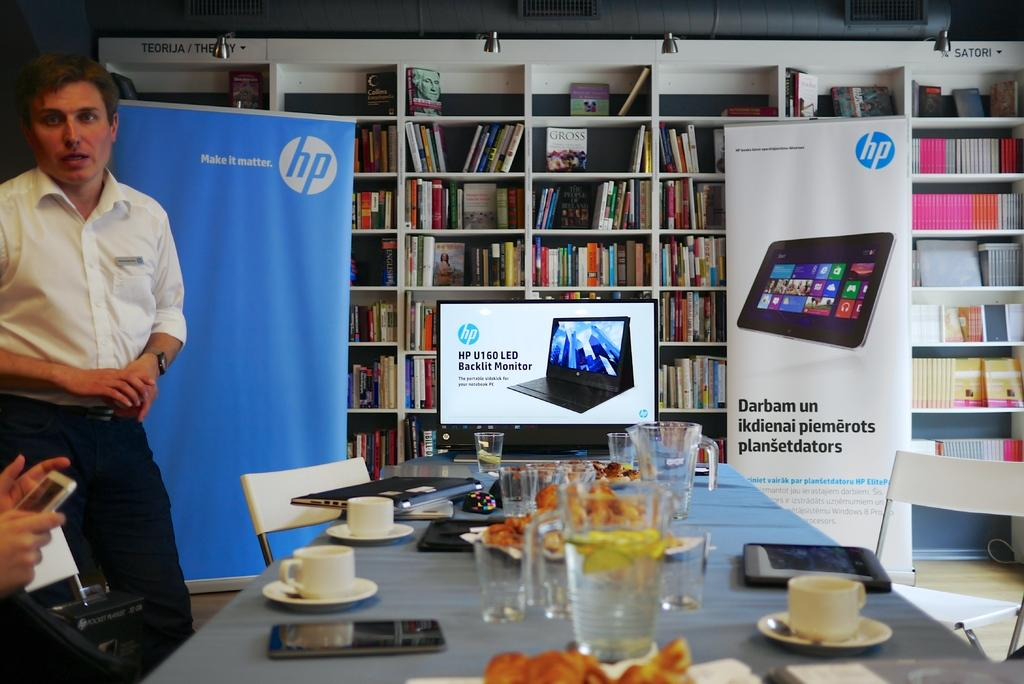<image>
Provide a brief description of the given image. A man stands near a table with HP logo on a blue display and an advertisement for an HP monitor behind him. 